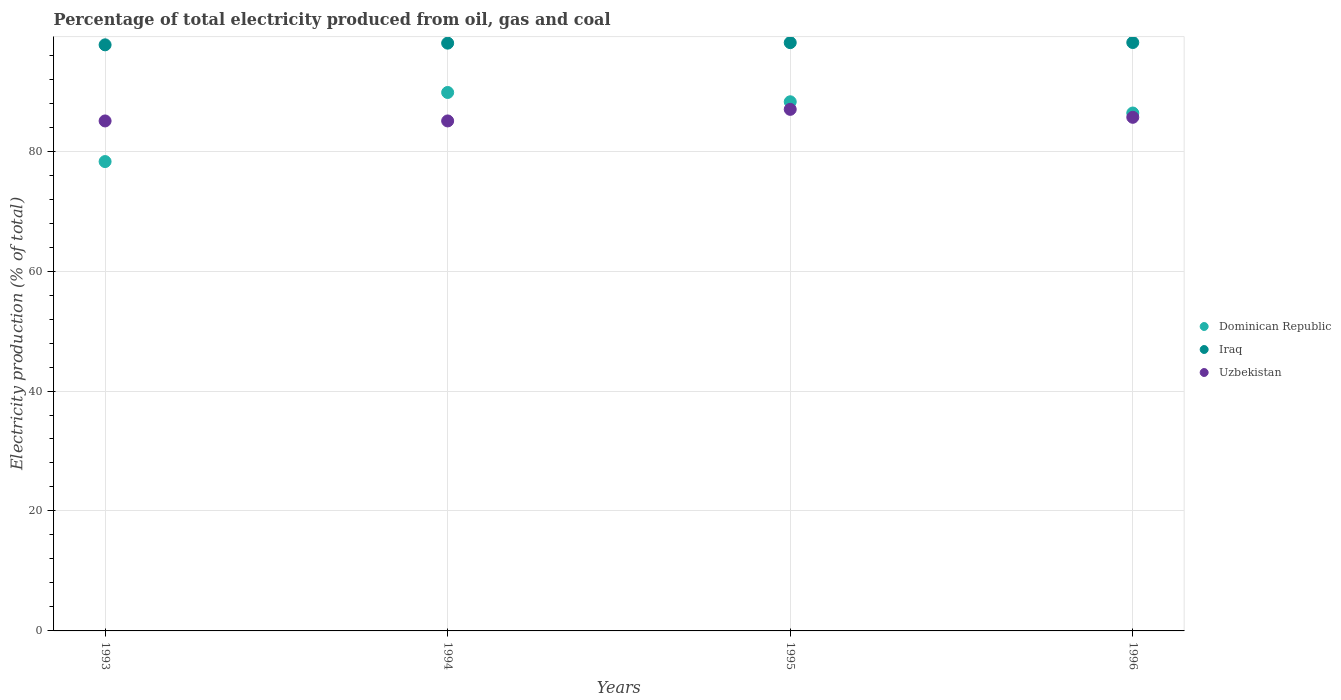How many different coloured dotlines are there?
Provide a succinct answer. 3. Is the number of dotlines equal to the number of legend labels?
Offer a very short reply. Yes. Across all years, what is the maximum electricity production in in Dominican Republic?
Give a very brief answer. 89.78. Across all years, what is the minimum electricity production in in Iraq?
Provide a short and direct response. 97.72. What is the total electricity production in in Uzbekistan in the graph?
Offer a terse response. 342.65. What is the difference between the electricity production in in Uzbekistan in 1994 and that in 1995?
Keep it short and to the point. -1.93. What is the difference between the electricity production in in Iraq in 1993 and the electricity production in in Dominican Republic in 1994?
Ensure brevity in your answer.  7.94. What is the average electricity production in in Dominican Republic per year?
Make the answer very short. 85.65. In the year 1993, what is the difference between the electricity production in in Uzbekistan and electricity production in in Dominican Republic?
Your answer should be very brief. 6.77. What is the ratio of the electricity production in in Dominican Republic in 1994 to that in 1996?
Provide a short and direct response. 1.04. Is the electricity production in in Iraq in 1994 less than that in 1995?
Provide a succinct answer. Yes. Is the difference between the electricity production in in Uzbekistan in 1993 and 1994 greater than the difference between the electricity production in in Dominican Republic in 1993 and 1994?
Your answer should be compact. Yes. What is the difference between the highest and the second highest electricity production in in Uzbekistan?
Your response must be concise. 1.33. What is the difference between the highest and the lowest electricity production in in Dominican Republic?
Provide a short and direct response. 11.52. In how many years, is the electricity production in in Dominican Republic greater than the average electricity production in in Dominican Republic taken over all years?
Your answer should be compact. 3. Does the electricity production in in Uzbekistan monotonically increase over the years?
Offer a terse response. No. Does the graph contain grids?
Your response must be concise. Yes. How many legend labels are there?
Provide a short and direct response. 3. What is the title of the graph?
Your answer should be very brief. Percentage of total electricity produced from oil, gas and coal. What is the label or title of the Y-axis?
Offer a very short reply. Electricity production (% of total). What is the Electricity production (% of total) of Dominican Republic in 1993?
Make the answer very short. 78.26. What is the Electricity production (% of total) in Iraq in 1993?
Provide a succinct answer. 97.72. What is the Electricity production (% of total) of Uzbekistan in 1993?
Offer a terse response. 85.03. What is the Electricity production (% of total) of Dominican Republic in 1994?
Give a very brief answer. 89.78. What is the Electricity production (% of total) of Iraq in 1994?
Make the answer very short. 98. What is the Electricity production (% of total) of Uzbekistan in 1994?
Give a very brief answer. 85.03. What is the Electricity production (% of total) in Dominican Republic in 1995?
Offer a terse response. 88.22. What is the Electricity production (% of total) in Iraq in 1995?
Your answer should be compact. 98.08. What is the Electricity production (% of total) of Uzbekistan in 1995?
Offer a very short reply. 86.96. What is the Electricity production (% of total) in Dominican Republic in 1996?
Offer a terse response. 86.35. What is the Electricity production (% of total) in Iraq in 1996?
Your response must be concise. 98.1. What is the Electricity production (% of total) in Uzbekistan in 1996?
Keep it short and to the point. 85.63. Across all years, what is the maximum Electricity production (% of total) in Dominican Republic?
Keep it short and to the point. 89.78. Across all years, what is the maximum Electricity production (% of total) in Iraq?
Keep it short and to the point. 98.1. Across all years, what is the maximum Electricity production (% of total) in Uzbekistan?
Give a very brief answer. 86.96. Across all years, what is the minimum Electricity production (% of total) in Dominican Republic?
Your answer should be compact. 78.26. Across all years, what is the minimum Electricity production (% of total) of Iraq?
Provide a succinct answer. 97.72. Across all years, what is the minimum Electricity production (% of total) in Uzbekistan?
Provide a short and direct response. 85.03. What is the total Electricity production (% of total) in Dominican Republic in the graph?
Offer a terse response. 342.6. What is the total Electricity production (% of total) of Iraq in the graph?
Make the answer very short. 391.9. What is the total Electricity production (% of total) in Uzbekistan in the graph?
Provide a succinct answer. 342.65. What is the difference between the Electricity production (% of total) of Dominican Republic in 1993 and that in 1994?
Provide a short and direct response. -11.52. What is the difference between the Electricity production (% of total) of Iraq in 1993 and that in 1994?
Keep it short and to the point. -0.28. What is the difference between the Electricity production (% of total) in Uzbekistan in 1993 and that in 1994?
Offer a terse response. -0. What is the difference between the Electricity production (% of total) of Dominican Republic in 1993 and that in 1995?
Offer a terse response. -9.97. What is the difference between the Electricity production (% of total) of Iraq in 1993 and that in 1995?
Provide a succinct answer. -0.36. What is the difference between the Electricity production (% of total) in Uzbekistan in 1993 and that in 1995?
Your response must be concise. -1.93. What is the difference between the Electricity production (% of total) in Dominican Republic in 1993 and that in 1996?
Offer a terse response. -8.09. What is the difference between the Electricity production (% of total) in Iraq in 1993 and that in 1996?
Provide a short and direct response. -0.38. What is the difference between the Electricity production (% of total) of Uzbekistan in 1993 and that in 1996?
Make the answer very short. -0.6. What is the difference between the Electricity production (% of total) in Dominican Republic in 1994 and that in 1995?
Offer a very short reply. 1.55. What is the difference between the Electricity production (% of total) in Iraq in 1994 and that in 1995?
Offer a very short reply. -0.08. What is the difference between the Electricity production (% of total) in Uzbekistan in 1994 and that in 1995?
Offer a very short reply. -1.93. What is the difference between the Electricity production (% of total) of Dominican Republic in 1994 and that in 1996?
Make the answer very short. 3.43. What is the difference between the Electricity production (% of total) of Iraq in 1994 and that in 1996?
Offer a very short reply. -0.1. What is the difference between the Electricity production (% of total) in Uzbekistan in 1994 and that in 1996?
Offer a very short reply. -0.6. What is the difference between the Electricity production (% of total) of Dominican Republic in 1995 and that in 1996?
Make the answer very short. 1.87. What is the difference between the Electricity production (% of total) of Iraq in 1995 and that in 1996?
Give a very brief answer. -0.02. What is the difference between the Electricity production (% of total) in Uzbekistan in 1995 and that in 1996?
Your answer should be very brief. 1.33. What is the difference between the Electricity production (% of total) in Dominican Republic in 1993 and the Electricity production (% of total) in Iraq in 1994?
Offer a very short reply. -19.74. What is the difference between the Electricity production (% of total) of Dominican Republic in 1993 and the Electricity production (% of total) of Uzbekistan in 1994?
Provide a succinct answer. -6.77. What is the difference between the Electricity production (% of total) in Iraq in 1993 and the Electricity production (% of total) in Uzbekistan in 1994?
Your response must be concise. 12.69. What is the difference between the Electricity production (% of total) of Dominican Republic in 1993 and the Electricity production (% of total) of Iraq in 1995?
Your answer should be compact. -19.83. What is the difference between the Electricity production (% of total) of Dominican Republic in 1993 and the Electricity production (% of total) of Uzbekistan in 1995?
Your answer should be compact. -8.7. What is the difference between the Electricity production (% of total) in Iraq in 1993 and the Electricity production (% of total) in Uzbekistan in 1995?
Make the answer very short. 10.76. What is the difference between the Electricity production (% of total) of Dominican Republic in 1993 and the Electricity production (% of total) of Iraq in 1996?
Provide a short and direct response. -19.85. What is the difference between the Electricity production (% of total) of Dominican Republic in 1993 and the Electricity production (% of total) of Uzbekistan in 1996?
Provide a short and direct response. -7.38. What is the difference between the Electricity production (% of total) in Iraq in 1993 and the Electricity production (% of total) in Uzbekistan in 1996?
Your answer should be compact. 12.08. What is the difference between the Electricity production (% of total) in Dominican Republic in 1994 and the Electricity production (% of total) in Iraq in 1995?
Keep it short and to the point. -8.31. What is the difference between the Electricity production (% of total) in Dominican Republic in 1994 and the Electricity production (% of total) in Uzbekistan in 1995?
Make the answer very short. 2.82. What is the difference between the Electricity production (% of total) in Iraq in 1994 and the Electricity production (% of total) in Uzbekistan in 1995?
Provide a succinct answer. 11.04. What is the difference between the Electricity production (% of total) of Dominican Republic in 1994 and the Electricity production (% of total) of Iraq in 1996?
Provide a succinct answer. -8.33. What is the difference between the Electricity production (% of total) in Dominican Republic in 1994 and the Electricity production (% of total) in Uzbekistan in 1996?
Offer a very short reply. 4.14. What is the difference between the Electricity production (% of total) in Iraq in 1994 and the Electricity production (% of total) in Uzbekistan in 1996?
Provide a succinct answer. 12.37. What is the difference between the Electricity production (% of total) in Dominican Republic in 1995 and the Electricity production (% of total) in Iraq in 1996?
Ensure brevity in your answer.  -9.88. What is the difference between the Electricity production (% of total) of Dominican Republic in 1995 and the Electricity production (% of total) of Uzbekistan in 1996?
Keep it short and to the point. 2.59. What is the difference between the Electricity production (% of total) of Iraq in 1995 and the Electricity production (% of total) of Uzbekistan in 1996?
Offer a terse response. 12.45. What is the average Electricity production (% of total) of Dominican Republic per year?
Ensure brevity in your answer.  85.65. What is the average Electricity production (% of total) in Iraq per year?
Provide a short and direct response. 97.98. What is the average Electricity production (% of total) in Uzbekistan per year?
Your answer should be very brief. 85.66. In the year 1993, what is the difference between the Electricity production (% of total) in Dominican Republic and Electricity production (% of total) in Iraq?
Your answer should be compact. -19.46. In the year 1993, what is the difference between the Electricity production (% of total) in Dominican Republic and Electricity production (% of total) in Uzbekistan?
Offer a very short reply. -6.77. In the year 1993, what is the difference between the Electricity production (% of total) in Iraq and Electricity production (% of total) in Uzbekistan?
Give a very brief answer. 12.69. In the year 1994, what is the difference between the Electricity production (% of total) of Dominican Republic and Electricity production (% of total) of Iraq?
Provide a short and direct response. -8.22. In the year 1994, what is the difference between the Electricity production (% of total) of Dominican Republic and Electricity production (% of total) of Uzbekistan?
Offer a terse response. 4.75. In the year 1994, what is the difference between the Electricity production (% of total) in Iraq and Electricity production (% of total) in Uzbekistan?
Offer a very short reply. 12.97. In the year 1995, what is the difference between the Electricity production (% of total) in Dominican Republic and Electricity production (% of total) in Iraq?
Provide a short and direct response. -9.86. In the year 1995, what is the difference between the Electricity production (% of total) in Dominican Republic and Electricity production (% of total) in Uzbekistan?
Offer a terse response. 1.26. In the year 1995, what is the difference between the Electricity production (% of total) of Iraq and Electricity production (% of total) of Uzbekistan?
Your answer should be compact. 11.12. In the year 1996, what is the difference between the Electricity production (% of total) in Dominican Republic and Electricity production (% of total) in Iraq?
Ensure brevity in your answer.  -11.75. In the year 1996, what is the difference between the Electricity production (% of total) in Dominican Republic and Electricity production (% of total) in Uzbekistan?
Provide a short and direct response. 0.72. In the year 1996, what is the difference between the Electricity production (% of total) of Iraq and Electricity production (% of total) of Uzbekistan?
Offer a terse response. 12.47. What is the ratio of the Electricity production (% of total) in Dominican Republic in 1993 to that in 1994?
Offer a terse response. 0.87. What is the ratio of the Electricity production (% of total) of Uzbekistan in 1993 to that in 1994?
Provide a succinct answer. 1. What is the ratio of the Electricity production (% of total) of Dominican Republic in 1993 to that in 1995?
Offer a very short reply. 0.89. What is the ratio of the Electricity production (% of total) of Uzbekistan in 1993 to that in 1995?
Give a very brief answer. 0.98. What is the ratio of the Electricity production (% of total) in Dominican Republic in 1993 to that in 1996?
Ensure brevity in your answer.  0.91. What is the ratio of the Electricity production (% of total) of Iraq in 1993 to that in 1996?
Your response must be concise. 1. What is the ratio of the Electricity production (% of total) in Uzbekistan in 1993 to that in 1996?
Your answer should be very brief. 0.99. What is the ratio of the Electricity production (% of total) in Dominican Republic in 1994 to that in 1995?
Give a very brief answer. 1.02. What is the ratio of the Electricity production (% of total) of Iraq in 1994 to that in 1995?
Your answer should be compact. 1. What is the ratio of the Electricity production (% of total) of Uzbekistan in 1994 to that in 1995?
Keep it short and to the point. 0.98. What is the ratio of the Electricity production (% of total) in Dominican Republic in 1994 to that in 1996?
Your answer should be compact. 1.04. What is the ratio of the Electricity production (% of total) in Dominican Republic in 1995 to that in 1996?
Make the answer very short. 1.02. What is the ratio of the Electricity production (% of total) of Uzbekistan in 1995 to that in 1996?
Keep it short and to the point. 1.02. What is the difference between the highest and the second highest Electricity production (% of total) in Dominican Republic?
Provide a succinct answer. 1.55. What is the difference between the highest and the second highest Electricity production (% of total) of Iraq?
Ensure brevity in your answer.  0.02. What is the difference between the highest and the second highest Electricity production (% of total) in Uzbekistan?
Your response must be concise. 1.33. What is the difference between the highest and the lowest Electricity production (% of total) in Dominican Republic?
Provide a succinct answer. 11.52. What is the difference between the highest and the lowest Electricity production (% of total) in Iraq?
Offer a terse response. 0.38. What is the difference between the highest and the lowest Electricity production (% of total) in Uzbekistan?
Provide a short and direct response. 1.93. 